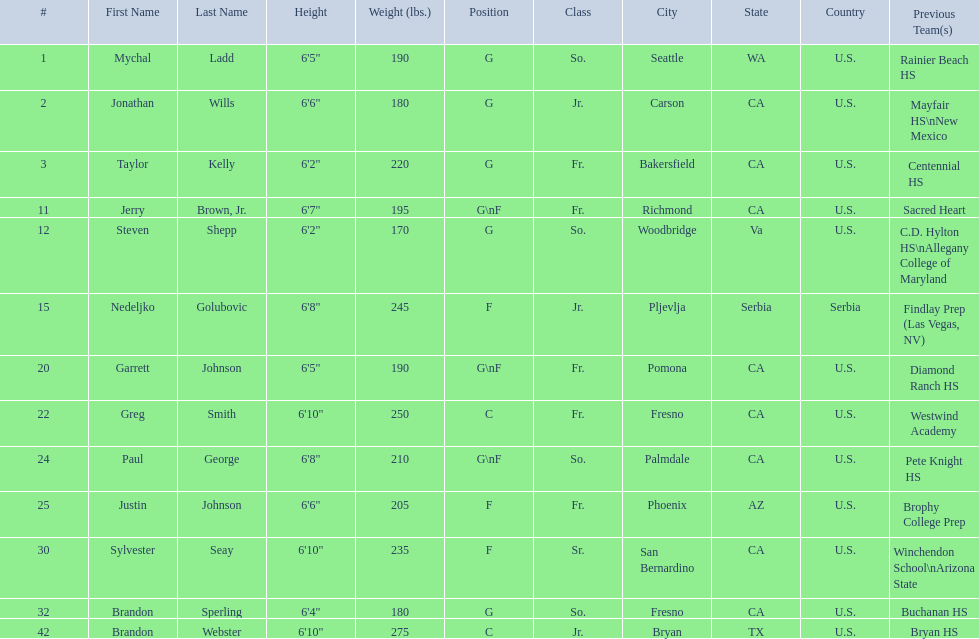Where were all of the players born? So., Jr., Fr., Fr., So., Jr., Fr., Fr., So., Fr., Sr., So., Jr. Who is the one from serbia? Nedeljko Golubovic. 